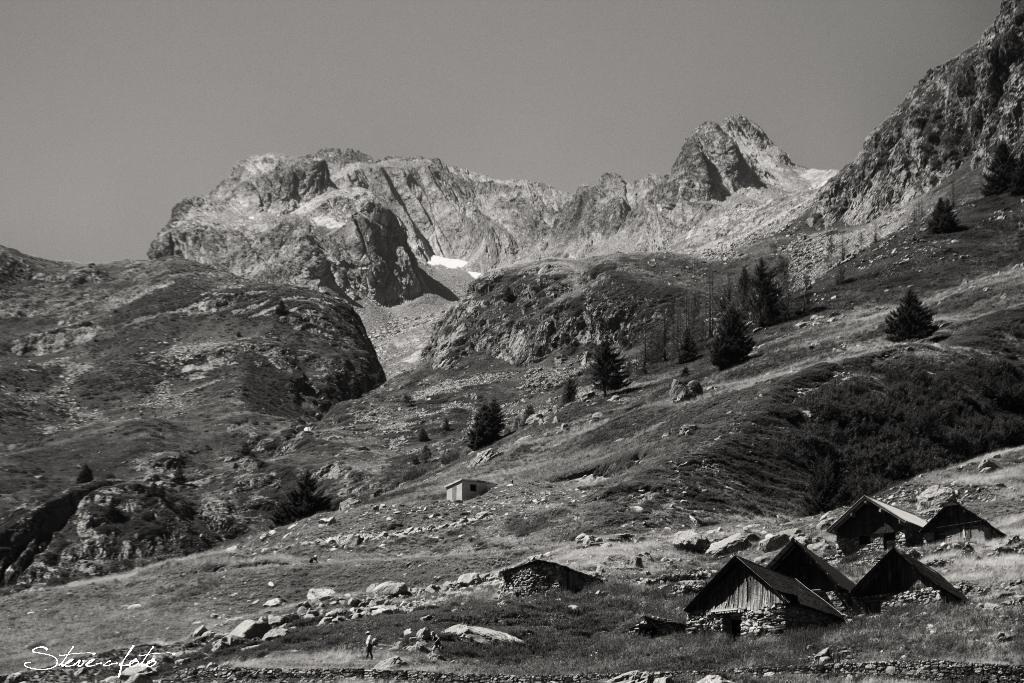What is the color scheme of the photograph? The photograph is black and white. What is the main subject of the photograph? The photograph depicts mountains. Are there any structures visible in the photograph? Yes, there are six small shed houses in the front bottom side of the image. What type of garden can be seen in the photograph? There is no garden present in the photograph; it features mountains and six small shed houses. What is the condition of the transport in the photograph? There is no transport present in the photograph, so it is not possible to determine its condition. 